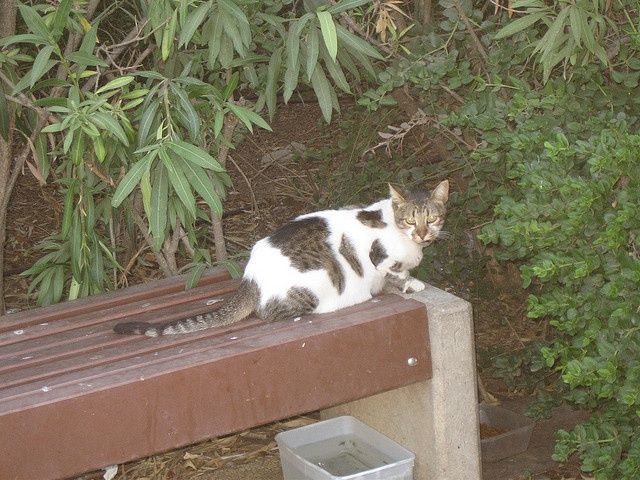Describe the objects in this image and their specific colors. I can see bench in black, gray, and darkgray tones, cat in black, white, gray, and darkgray tones, bowl in black, darkgray, and gray tones, and bowl in black, gray, and maroon tones in this image. 